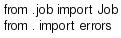Convert code to text. <code><loc_0><loc_0><loc_500><loc_500><_Python_>from .job import Job
from . import errors

</code> 